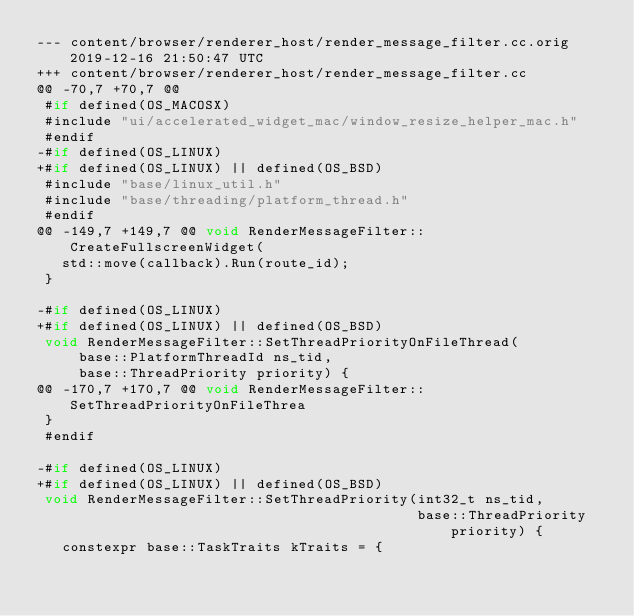Convert code to text. <code><loc_0><loc_0><loc_500><loc_500><_C++_>--- content/browser/renderer_host/render_message_filter.cc.orig	2019-12-16 21:50:47 UTC
+++ content/browser/renderer_host/render_message_filter.cc
@@ -70,7 +70,7 @@
 #if defined(OS_MACOSX)
 #include "ui/accelerated_widget_mac/window_resize_helper_mac.h"
 #endif
-#if defined(OS_LINUX)
+#if defined(OS_LINUX) || defined(OS_BSD)
 #include "base/linux_util.h"
 #include "base/threading/platform_thread.h"
 #endif
@@ -149,7 +149,7 @@ void RenderMessageFilter::CreateFullscreenWidget(
   std::move(callback).Run(route_id);
 }
 
-#if defined(OS_LINUX)
+#if defined(OS_LINUX) || defined(OS_BSD)
 void RenderMessageFilter::SetThreadPriorityOnFileThread(
     base::PlatformThreadId ns_tid,
     base::ThreadPriority priority) {
@@ -170,7 +170,7 @@ void RenderMessageFilter::SetThreadPriorityOnFileThrea
 }
 #endif
 
-#if defined(OS_LINUX)
+#if defined(OS_LINUX) || defined(OS_BSD)
 void RenderMessageFilter::SetThreadPriority(int32_t ns_tid,
                                             base::ThreadPriority priority) {
   constexpr base::TaskTraits kTraits = {
</code> 